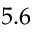<formula> <loc_0><loc_0><loc_500><loc_500>5 . 6</formula> 